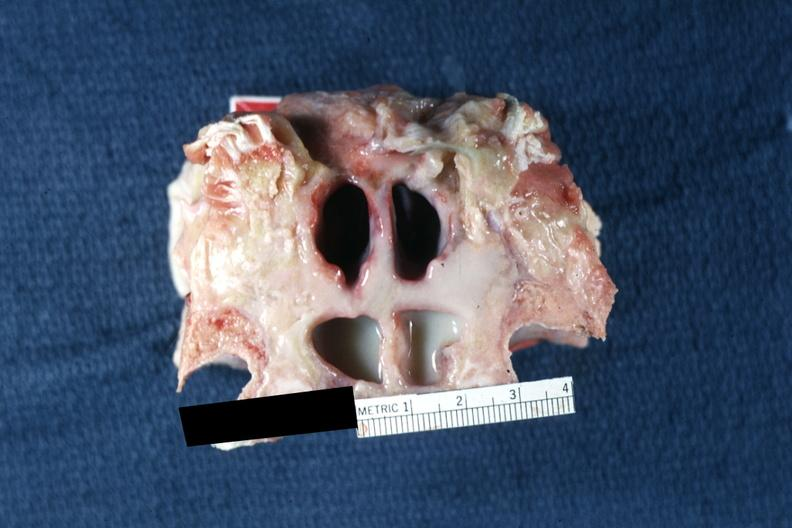s purulent sinusitis present?
Answer the question using a single word or phrase. Yes 